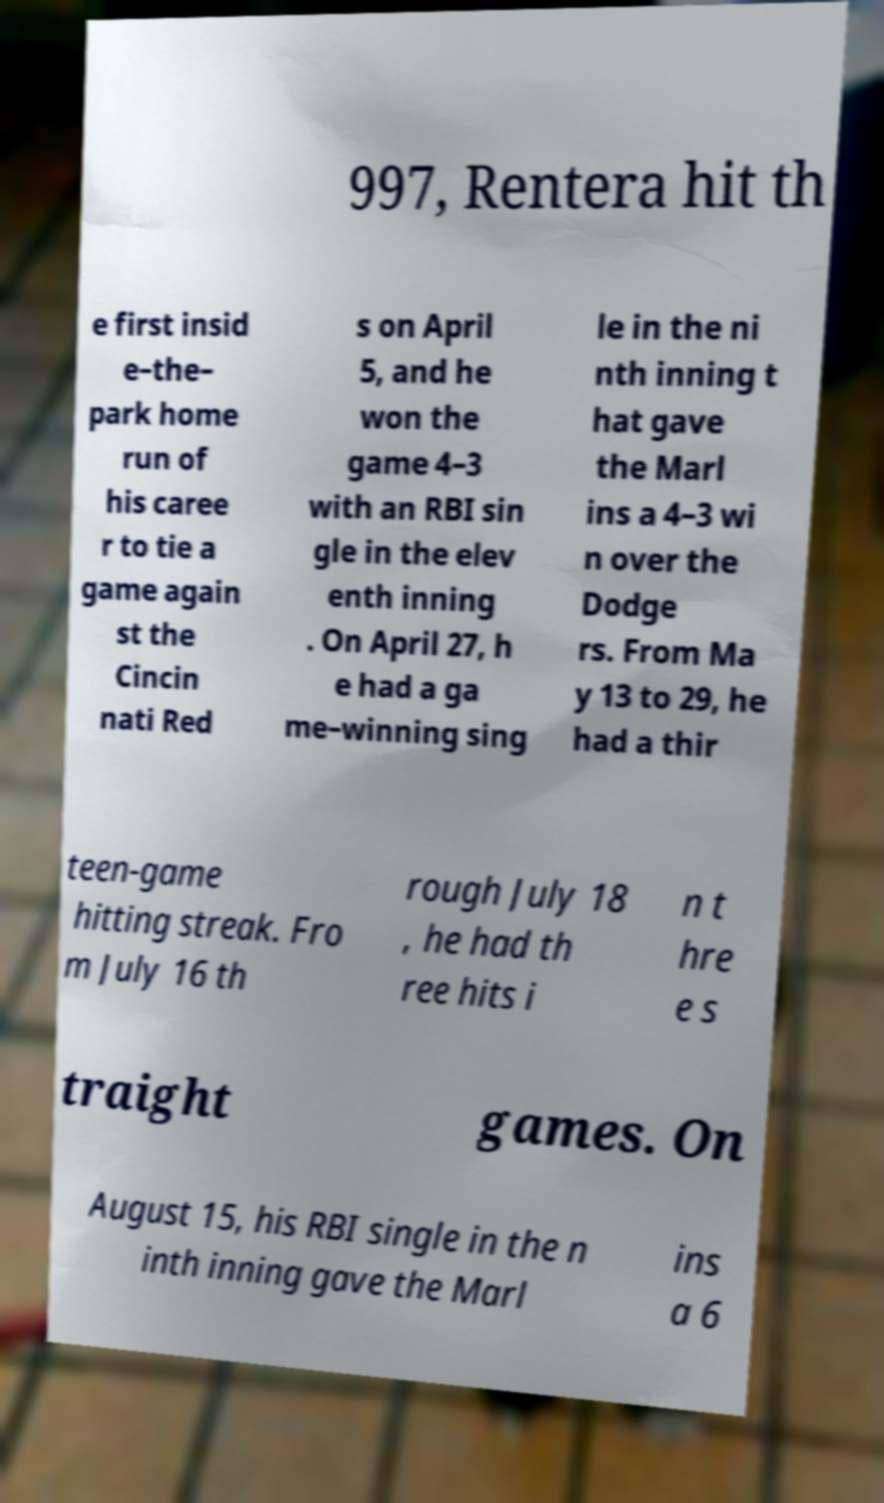There's text embedded in this image that I need extracted. Can you transcribe it verbatim? 997, Rentera hit th e first insid e–the– park home run of his caree r to tie a game again st the Cincin nati Red s on April 5, and he won the game 4–3 with an RBI sin gle in the elev enth inning . On April 27, h e had a ga me–winning sing le in the ni nth inning t hat gave the Marl ins a 4–3 wi n over the Dodge rs. From Ma y 13 to 29, he had a thir teen-game hitting streak. Fro m July 16 th rough July 18 , he had th ree hits i n t hre e s traight games. On August 15, his RBI single in the n inth inning gave the Marl ins a 6 